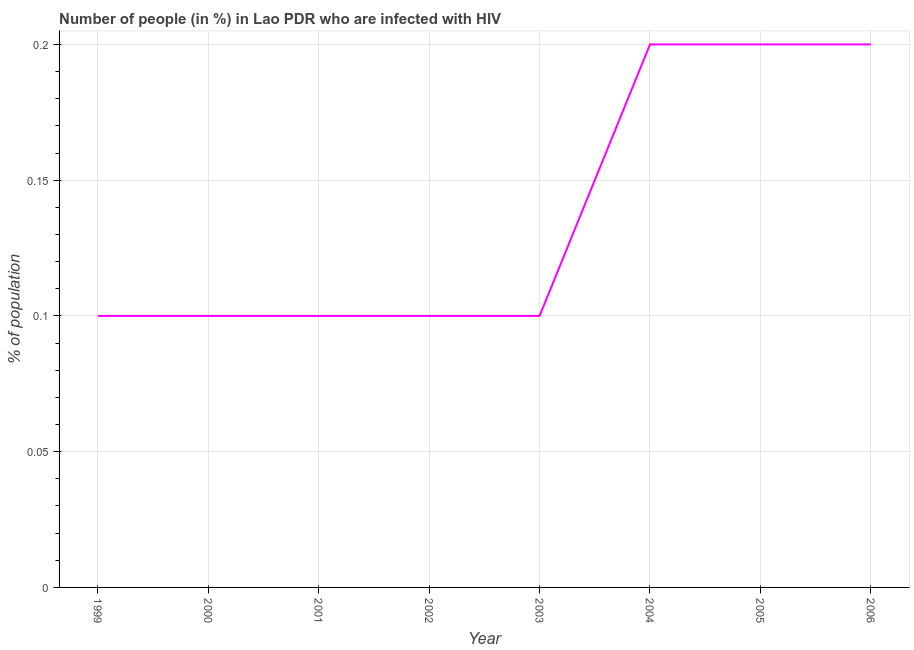What is the number of people infected with hiv in 2006?
Your answer should be very brief. 0.2. Across all years, what is the maximum number of people infected with hiv?
Keep it short and to the point. 0.2. Across all years, what is the minimum number of people infected with hiv?
Your response must be concise. 0.1. In which year was the number of people infected with hiv maximum?
Your answer should be very brief. 2004. What is the sum of the number of people infected with hiv?
Keep it short and to the point. 1.1. What is the average number of people infected with hiv per year?
Provide a short and direct response. 0.14. What is the ratio of the number of people infected with hiv in 1999 to that in 2005?
Your response must be concise. 0.5. Is the difference between the number of people infected with hiv in 1999 and 2001 greater than the difference between any two years?
Keep it short and to the point. No. Is the sum of the number of people infected with hiv in 1999 and 2006 greater than the maximum number of people infected with hiv across all years?
Your answer should be compact. Yes. In how many years, is the number of people infected with hiv greater than the average number of people infected with hiv taken over all years?
Your response must be concise. 3. Does the number of people infected with hiv monotonically increase over the years?
Offer a very short reply. No. How many lines are there?
Your answer should be very brief. 1. What is the difference between two consecutive major ticks on the Y-axis?
Offer a very short reply. 0.05. What is the title of the graph?
Offer a terse response. Number of people (in %) in Lao PDR who are infected with HIV. What is the label or title of the X-axis?
Give a very brief answer. Year. What is the label or title of the Y-axis?
Make the answer very short. % of population. What is the % of population of 2001?
Keep it short and to the point. 0.1. What is the % of population in 2002?
Your answer should be very brief. 0.1. What is the % of population in 2003?
Offer a very short reply. 0.1. What is the % of population of 2004?
Ensure brevity in your answer.  0.2. What is the % of population in 2005?
Your answer should be compact. 0.2. What is the difference between the % of population in 1999 and 2000?
Keep it short and to the point. 0. What is the difference between the % of population in 1999 and 2006?
Keep it short and to the point. -0.1. What is the difference between the % of population in 2000 and 2001?
Offer a terse response. 0. What is the difference between the % of population in 2000 and 2004?
Keep it short and to the point. -0.1. What is the difference between the % of population in 2000 and 2006?
Give a very brief answer. -0.1. What is the difference between the % of population in 2001 and 2003?
Keep it short and to the point. 0. What is the difference between the % of population in 2001 and 2006?
Make the answer very short. -0.1. What is the difference between the % of population in 2003 and 2004?
Offer a terse response. -0.1. What is the difference between the % of population in 2003 and 2005?
Offer a terse response. -0.1. What is the difference between the % of population in 2005 and 2006?
Your answer should be very brief. 0. What is the ratio of the % of population in 1999 to that in 2004?
Your response must be concise. 0.5. What is the ratio of the % of population in 1999 to that in 2006?
Make the answer very short. 0.5. What is the ratio of the % of population in 2000 to that in 2002?
Your answer should be compact. 1. What is the ratio of the % of population in 2000 to that in 2004?
Make the answer very short. 0.5. What is the ratio of the % of population in 2000 to that in 2005?
Your answer should be very brief. 0.5. What is the ratio of the % of population in 2001 to that in 2004?
Offer a very short reply. 0.5. What is the ratio of the % of population in 2001 to that in 2006?
Offer a very short reply. 0.5. What is the ratio of the % of population in 2002 to that in 2003?
Your response must be concise. 1. What is the ratio of the % of population in 2002 to that in 2004?
Keep it short and to the point. 0.5. What is the ratio of the % of population in 2002 to that in 2006?
Your answer should be compact. 0.5. What is the ratio of the % of population in 2004 to that in 2006?
Offer a very short reply. 1. What is the ratio of the % of population in 2005 to that in 2006?
Your answer should be compact. 1. 